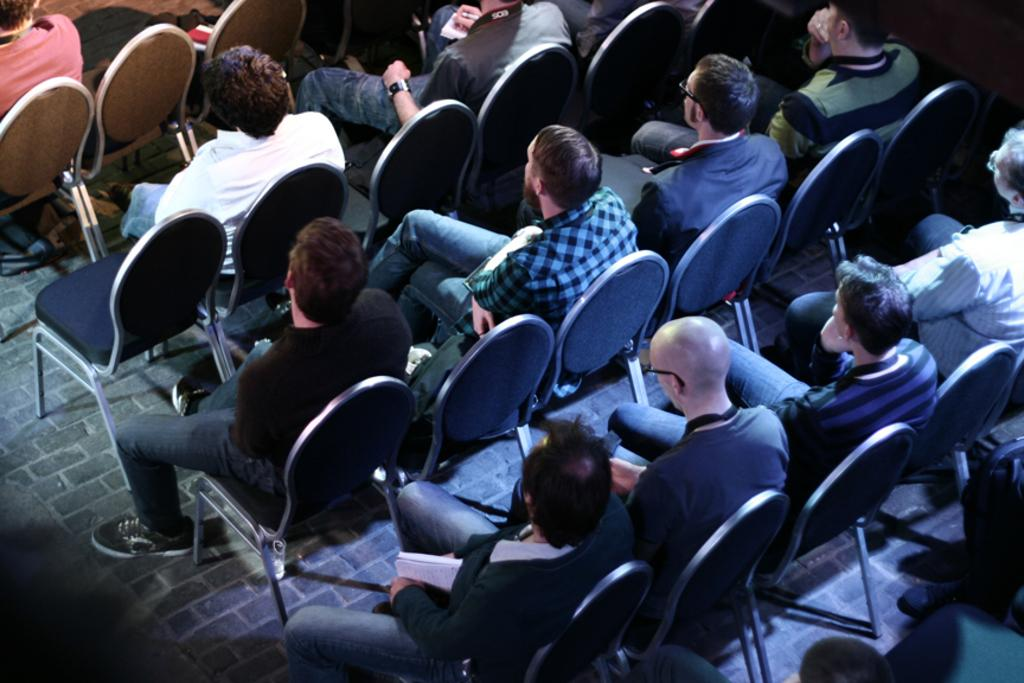Where was the image taken? The image was taken in a room. What furniture can be seen in the room? The room contains chairs. Are there any people in the room? Yes, there are people in the room. What are the people doing in the image? The people are staring backwards. What key is being used to unlock the door in the image? There is no door or key present in the image; it only shows people staring backwards in a room with chairs. 